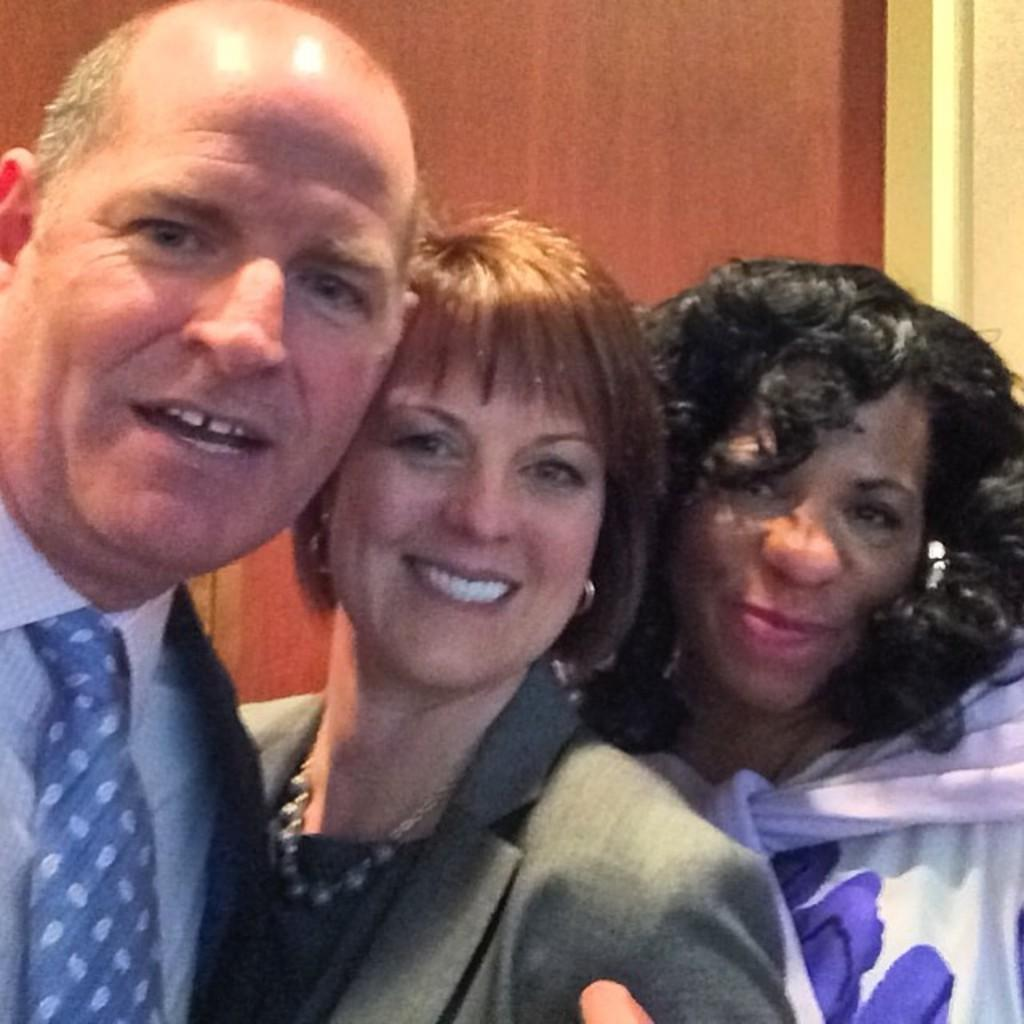How many people are in the image? There are three persons in the image. What are the people wearing? The persons are wearing clothes. Where is the throne located in the image? There is no throne present in the image. What type of cheese is being served on the table in the image? There is no cheese or table present in the image. 